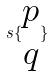<formula> <loc_0><loc_0><loc_500><loc_500>s \{ \begin{matrix} p \\ q \end{matrix} \}</formula> 